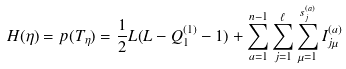<formula> <loc_0><loc_0><loc_500><loc_500>H ( \eta ) = { p } ( T _ { \eta } ) = { \frac { 1 } { 2 } } L ( L - Q _ { 1 } ^ { ( 1 ) } - 1 ) + \sum _ { a = 1 } ^ { n - 1 } \sum _ { j = 1 } ^ { \ell } \sum _ { \mu = 1 } ^ { s _ { j } ^ { ( a ) } } I _ { j \mu } ^ { ( a ) }</formula> 